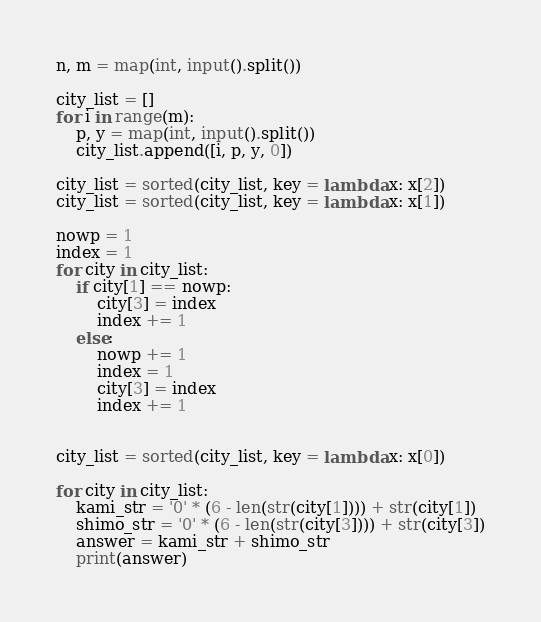<code> <loc_0><loc_0><loc_500><loc_500><_Python_>n, m = map(int, input().split())

city_list = []
for i in range(m):
	p, y = map(int, input().split())
	city_list.append([i, p, y, 0])

city_list = sorted(city_list, key = lambda x: x[2])
city_list = sorted(city_list, key = lambda x: x[1])

nowp = 1
index = 1
for city in city_list:
	if city[1] == nowp:
		city[3] = index
		index += 1
	else:
		nowp += 1
		index = 1
		city[3] = index
		index += 1


city_list = sorted(city_list, key = lambda x: x[0])

for city in city_list:
	kami_str = '0' * (6 - len(str(city[1]))) + str(city[1])
	shimo_str = '0' * (6 - len(str(city[3]))) + str(city[3])
	answer = kami_str + shimo_str
	print(answer)
</code> 